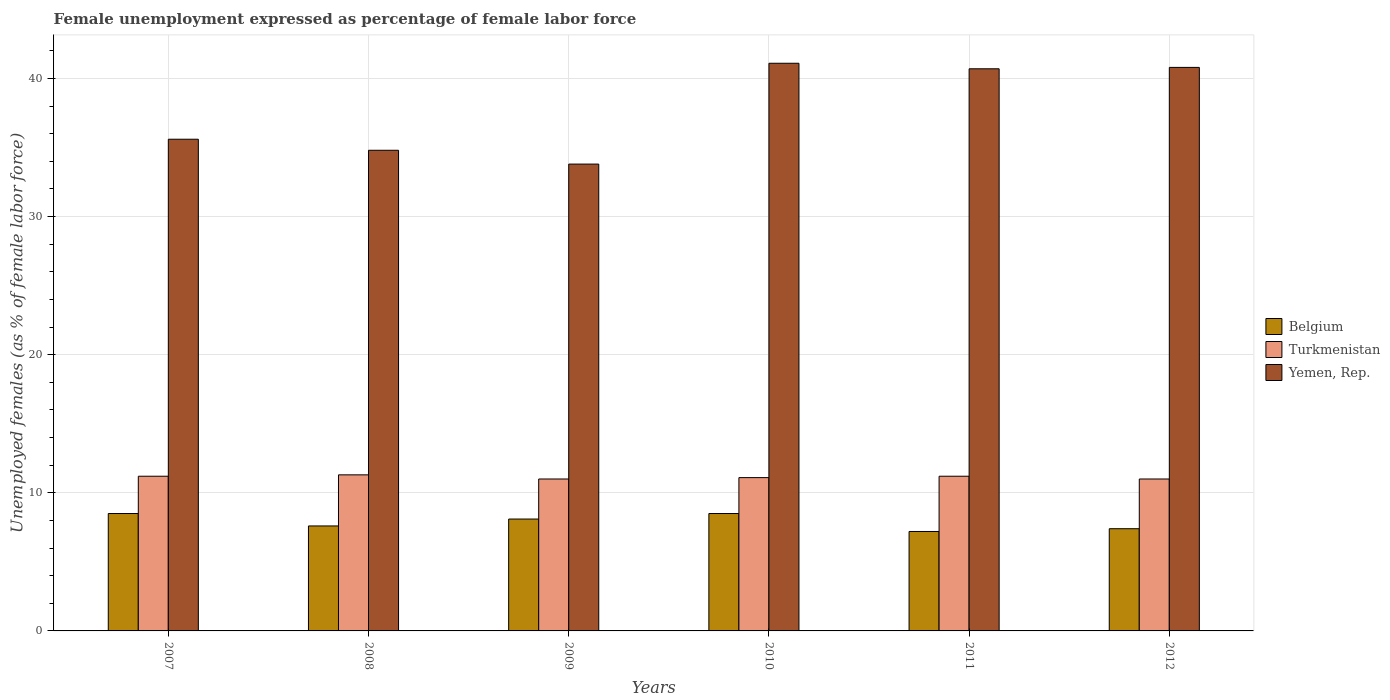How many different coloured bars are there?
Ensure brevity in your answer.  3. How many bars are there on the 4th tick from the left?
Ensure brevity in your answer.  3. What is the label of the 3rd group of bars from the left?
Offer a very short reply. 2009. In how many cases, is the number of bars for a given year not equal to the number of legend labels?
Keep it short and to the point. 0. What is the unemployment in females in in Belgium in 2007?
Provide a succinct answer. 8.5. Across all years, what is the maximum unemployment in females in in Belgium?
Provide a succinct answer. 8.5. In which year was the unemployment in females in in Turkmenistan minimum?
Keep it short and to the point. 2009. What is the total unemployment in females in in Turkmenistan in the graph?
Offer a terse response. 66.8. What is the difference between the unemployment in females in in Turkmenistan in 2009 and that in 2010?
Your answer should be very brief. -0.1. What is the difference between the unemployment in females in in Belgium in 2007 and the unemployment in females in in Yemen, Rep. in 2009?
Offer a terse response. -25.3. What is the average unemployment in females in in Belgium per year?
Ensure brevity in your answer.  7.88. In the year 2007, what is the difference between the unemployment in females in in Turkmenistan and unemployment in females in in Yemen, Rep.?
Your response must be concise. -24.4. What is the ratio of the unemployment in females in in Belgium in 2010 to that in 2012?
Provide a succinct answer. 1.15. Is the difference between the unemployment in females in in Turkmenistan in 2011 and 2012 greater than the difference between the unemployment in females in in Yemen, Rep. in 2011 and 2012?
Make the answer very short. Yes. What is the difference between the highest and the second highest unemployment in females in in Turkmenistan?
Your answer should be compact. 0.1. What is the difference between the highest and the lowest unemployment in females in in Turkmenistan?
Offer a very short reply. 0.3. What does the 3rd bar from the left in 2007 represents?
Make the answer very short. Yemen, Rep. What does the 1st bar from the right in 2010 represents?
Make the answer very short. Yemen, Rep. Is it the case that in every year, the sum of the unemployment in females in in Turkmenistan and unemployment in females in in Yemen, Rep. is greater than the unemployment in females in in Belgium?
Keep it short and to the point. Yes. What is the difference between two consecutive major ticks on the Y-axis?
Provide a succinct answer. 10. How many legend labels are there?
Offer a terse response. 3. What is the title of the graph?
Give a very brief answer. Female unemployment expressed as percentage of female labor force. What is the label or title of the Y-axis?
Provide a succinct answer. Unemployed females (as % of female labor force). What is the Unemployed females (as % of female labor force) of Turkmenistan in 2007?
Offer a very short reply. 11.2. What is the Unemployed females (as % of female labor force) of Yemen, Rep. in 2007?
Ensure brevity in your answer.  35.6. What is the Unemployed females (as % of female labor force) of Belgium in 2008?
Your answer should be very brief. 7.6. What is the Unemployed females (as % of female labor force) in Turkmenistan in 2008?
Provide a succinct answer. 11.3. What is the Unemployed females (as % of female labor force) in Yemen, Rep. in 2008?
Ensure brevity in your answer.  34.8. What is the Unemployed females (as % of female labor force) of Belgium in 2009?
Keep it short and to the point. 8.1. What is the Unemployed females (as % of female labor force) in Yemen, Rep. in 2009?
Your answer should be compact. 33.8. What is the Unemployed females (as % of female labor force) in Belgium in 2010?
Keep it short and to the point. 8.5. What is the Unemployed females (as % of female labor force) of Turkmenistan in 2010?
Provide a short and direct response. 11.1. What is the Unemployed females (as % of female labor force) in Yemen, Rep. in 2010?
Ensure brevity in your answer.  41.1. What is the Unemployed females (as % of female labor force) of Belgium in 2011?
Ensure brevity in your answer.  7.2. What is the Unemployed females (as % of female labor force) in Turkmenistan in 2011?
Give a very brief answer. 11.2. What is the Unemployed females (as % of female labor force) in Yemen, Rep. in 2011?
Give a very brief answer. 40.7. What is the Unemployed females (as % of female labor force) of Belgium in 2012?
Provide a succinct answer. 7.4. What is the Unemployed females (as % of female labor force) of Yemen, Rep. in 2012?
Your answer should be very brief. 40.8. Across all years, what is the maximum Unemployed females (as % of female labor force) of Belgium?
Keep it short and to the point. 8.5. Across all years, what is the maximum Unemployed females (as % of female labor force) of Turkmenistan?
Offer a terse response. 11.3. Across all years, what is the maximum Unemployed females (as % of female labor force) of Yemen, Rep.?
Make the answer very short. 41.1. Across all years, what is the minimum Unemployed females (as % of female labor force) in Belgium?
Your answer should be compact. 7.2. Across all years, what is the minimum Unemployed females (as % of female labor force) in Turkmenistan?
Provide a short and direct response. 11. Across all years, what is the minimum Unemployed females (as % of female labor force) of Yemen, Rep.?
Keep it short and to the point. 33.8. What is the total Unemployed females (as % of female labor force) in Belgium in the graph?
Give a very brief answer. 47.3. What is the total Unemployed females (as % of female labor force) of Turkmenistan in the graph?
Keep it short and to the point. 66.8. What is the total Unemployed females (as % of female labor force) of Yemen, Rep. in the graph?
Provide a succinct answer. 226.8. What is the difference between the Unemployed females (as % of female labor force) in Belgium in 2007 and that in 2008?
Provide a succinct answer. 0.9. What is the difference between the Unemployed females (as % of female labor force) of Yemen, Rep. in 2007 and that in 2008?
Offer a terse response. 0.8. What is the difference between the Unemployed females (as % of female labor force) in Belgium in 2007 and that in 2009?
Provide a succinct answer. 0.4. What is the difference between the Unemployed females (as % of female labor force) of Turkmenistan in 2007 and that in 2009?
Your answer should be compact. 0.2. What is the difference between the Unemployed females (as % of female labor force) of Belgium in 2007 and that in 2012?
Make the answer very short. 1.1. What is the difference between the Unemployed females (as % of female labor force) of Yemen, Rep. in 2007 and that in 2012?
Provide a succinct answer. -5.2. What is the difference between the Unemployed females (as % of female labor force) in Belgium in 2008 and that in 2009?
Your response must be concise. -0.5. What is the difference between the Unemployed females (as % of female labor force) of Turkmenistan in 2008 and that in 2010?
Give a very brief answer. 0.2. What is the difference between the Unemployed females (as % of female labor force) in Yemen, Rep. in 2008 and that in 2010?
Your answer should be compact. -6.3. What is the difference between the Unemployed females (as % of female labor force) of Yemen, Rep. in 2008 and that in 2011?
Make the answer very short. -5.9. What is the difference between the Unemployed females (as % of female labor force) in Yemen, Rep. in 2008 and that in 2012?
Provide a succinct answer. -6. What is the difference between the Unemployed females (as % of female labor force) in Belgium in 2009 and that in 2011?
Ensure brevity in your answer.  0.9. What is the difference between the Unemployed females (as % of female labor force) of Yemen, Rep. in 2009 and that in 2011?
Give a very brief answer. -6.9. What is the difference between the Unemployed females (as % of female labor force) in Yemen, Rep. in 2009 and that in 2012?
Provide a short and direct response. -7. What is the difference between the Unemployed females (as % of female labor force) of Belgium in 2010 and that in 2011?
Provide a succinct answer. 1.3. What is the difference between the Unemployed females (as % of female labor force) of Turkmenistan in 2010 and that in 2011?
Ensure brevity in your answer.  -0.1. What is the difference between the Unemployed females (as % of female labor force) in Yemen, Rep. in 2010 and that in 2011?
Your answer should be very brief. 0.4. What is the difference between the Unemployed females (as % of female labor force) of Turkmenistan in 2010 and that in 2012?
Provide a short and direct response. 0.1. What is the difference between the Unemployed females (as % of female labor force) in Belgium in 2011 and that in 2012?
Keep it short and to the point. -0.2. What is the difference between the Unemployed females (as % of female labor force) in Turkmenistan in 2011 and that in 2012?
Offer a very short reply. 0.2. What is the difference between the Unemployed females (as % of female labor force) of Belgium in 2007 and the Unemployed females (as % of female labor force) of Turkmenistan in 2008?
Make the answer very short. -2.8. What is the difference between the Unemployed females (as % of female labor force) in Belgium in 2007 and the Unemployed females (as % of female labor force) in Yemen, Rep. in 2008?
Your response must be concise. -26.3. What is the difference between the Unemployed females (as % of female labor force) in Turkmenistan in 2007 and the Unemployed females (as % of female labor force) in Yemen, Rep. in 2008?
Give a very brief answer. -23.6. What is the difference between the Unemployed females (as % of female labor force) of Belgium in 2007 and the Unemployed females (as % of female labor force) of Yemen, Rep. in 2009?
Provide a succinct answer. -25.3. What is the difference between the Unemployed females (as % of female labor force) of Turkmenistan in 2007 and the Unemployed females (as % of female labor force) of Yemen, Rep. in 2009?
Ensure brevity in your answer.  -22.6. What is the difference between the Unemployed females (as % of female labor force) of Belgium in 2007 and the Unemployed females (as % of female labor force) of Yemen, Rep. in 2010?
Offer a terse response. -32.6. What is the difference between the Unemployed females (as % of female labor force) in Turkmenistan in 2007 and the Unemployed females (as % of female labor force) in Yemen, Rep. in 2010?
Ensure brevity in your answer.  -29.9. What is the difference between the Unemployed females (as % of female labor force) in Belgium in 2007 and the Unemployed females (as % of female labor force) in Turkmenistan in 2011?
Ensure brevity in your answer.  -2.7. What is the difference between the Unemployed females (as % of female labor force) in Belgium in 2007 and the Unemployed females (as % of female labor force) in Yemen, Rep. in 2011?
Your answer should be very brief. -32.2. What is the difference between the Unemployed females (as % of female labor force) in Turkmenistan in 2007 and the Unemployed females (as % of female labor force) in Yemen, Rep. in 2011?
Provide a succinct answer. -29.5. What is the difference between the Unemployed females (as % of female labor force) in Belgium in 2007 and the Unemployed females (as % of female labor force) in Yemen, Rep. in 2012?
Keep it short and to the point. -32.3. What is the difference between the Unemployed females (as % of female labor force) in Turkmenistan in 2007 and the Unemployed females (as % of female labor force) in Yemen, Rep. in 2012?
Provide a succinct answer. -29.6. What is the difference between the Unemployed females (as % of female labor force) in Belgium in 2008 and the Unemployed females (as % of female labor force) in Yemen, Rep. in 2009?
Ensure brevity in your answer.  -26.2. What is the difference between the Unemployed females (as % of female labor force) of Turkmenistan in 2008 and the Unemployed females (as % of female labor force) of Yemen, Rep. in 2009?
Keep it short and to the point. -22.5. What is the difference between the Unemployed females (as % of female labor force) of Belgium in 2008 and the Unemployed females (as % of female labor force) of Turkmenistan in 2010?
Your answer should be compact. -3.5. What is the difference between the Unemployed females (as % of female labor force) in Belgium in 2008 and the Unemployed females (as % of female labor force) in Yemen, Rep. in 2010?
Make the answer very short. -33.5. What is the difference between the Unemployed females (as % of female labor force) in Turkmenistan in 2008 and the Unemployed females (as % of female labor force) in Yemen, Rep. in 2010?
Give a very brief answer. -29.8. What is the difference between the Unemployed females (as % of female labor force) of Belgium in 2008 and the Unemployed females (as % of female labor force) of Turkmenistan in 2011?
Provide a succinct answer. -3.6. What is the difference between the Unemployed females (as % of female labor force) in Belgium in 2008 and the Unemployed females (as % of female labor force) in Yemen, Rep. in 2011?
Your response must be concise. -33.1. What is the difference between the Unemployed females (as % of female labor force) of Turkmenistan in 2008 and the Unemployed females (as % of female labor force) of Yemen, Rep. in 2011?
Your response must be concise. -29.4. What is the difference between the Unemployed females (as % of female labor force) of Belgium in 2008 and the Unemployed females (as % of female labor force) of Turkmenistan in 2012?
Keep it short and to the point. -3.4. What is the difference between the Unemployed females (as % of female labor force) of Belgium in 2008 and the Unemployed females (as % of female labor force) of Yemen, Rep. in 2012?
Offer a very short reply. -33.2. What is the difference between the Unemployed females (as % of female labor force) in Turkmenistan in 2008 and the Unemployed females (as % of female labor force) in Yemen, Rep. in 2012?
Your answer should be compact. -29.5. What is the difference between the Unemployed females (as % of female labor force) in Belgium in 2009 and the Unemployed females (as % of female labor force) in Yemen, Rep. in 2010?
Ensure brevity in your answer.  -33. What is the difference between the Unemployed females (as % of female labor force) in Turkmenistan in 2009 and the Unemployed females (as % of female labor force) in Yemen, Rep. in 2010?
Your answer should be very brief. -30.1. What is the difference between the Unemployed females (as % of female labor force) of Belgium in 2009 and the Unemployed females (as % of female labor force) of Yemen, Rep. in 2011?
Offer a terse response. -32.6. What is the difference between the Unemployed females (as % of female labor force) in Turkmenistan in 2009 and the Unemployed females (as % of female labor force) in Yemen, Rep. in 2011?
Offer a very short reply. -29.7. What is the difference between the Unemployed females (as % of female labor force) in Belgium in 2009 and the Unemployed females (as % of female labor force) in Turkmenistan in 2012?
Ensure brevity in your answer.  -2.9. What is the difference between the Unemployed females (as % of female labor force) of Belgium in 2009 and the Unemployed females (as % of female labor force) of Yemen, Rep. in 2012?
Give a very brief answer. -32.7. What is the difference between the Unemployed females (as % of female labor force) in Turkmenistan in 2009 and the Unemployed females (as % of female labor force) in Yemen, Rep. in 2012?
Offer a terse response. -29.8. What is the difference between the Unemployed females (as % of female labor force) of Belgium in 2010 and the Unemployed females (as % of female labor force) of Turkmenistan in 2011?
Offer a terse response. -2.7. What is the difference between the Unemployed females (as % of female labor force) of Belgium in 2010 and the Unemployed females (as % of female labor force) of Yemen, Rep. in 2011?
Provide a succinct answer. -32.2. What is the difference between the Unemployed females (as % of female labor force) of Turkmenistan in 2010 and the Unemployed females (as % of female labor force) of Yemen, Rep. in 2011?
Offer a very short reply. -29.6. What is the difference between the Unemployed females (as % of female labor force) in Belgium in 2010 and the Unemployed females (as % of female labor force) in Turkmenistan in 2012?
Your answer should be very brief. -2.5. What is the difference between the Unemployed females (as % of female labor force) in Belgium in 2010 and the Unemployed females (as % of female labor force) in Yemen, Rep. in 2012?
Ensure brevity in your answer.  -32.3. What is the difference between the Unemployed females (as % of female labor force) in Turkmenistan in 2010 and the Unemployed females (as % of female labor force) in Yemen, Rep. in 2012?
Your answer should be very brief. -29.7. What is the difference between the Unemployed females (as % of female labor force) of Belgium in 2011 and the Unemployed females (as % of female labor force) of Turkmenistan in 2012?
Provide a short and direct response. -3.8. What is the difference between the Unemployed females (as % of female labor force) in Belgium in 2011 and the Unemployed females (as % of female labor force) in Yemen, Rep. in 2012?
Provide a short and direct response. -33.6. What is the difference between the Unemployed females (as % of female labor force) of Turkmenistan in 2011 and the Unemployed females (as % of female labor force) of Yemen, Rep. in 2012?
Give a very brief answer. -29.6. What is the average Unemployed females (as % of female labor force) of Belgium per year?
Your response must be concise. 7.88. What is the average Unemployed females (as % of female labor force) in Turkmenistan per year?
Your answer should be very brief. 11.13. What is the average Unemployed females (as % of female labor force) in Yemen, Rep. per year?
Give a very brief answer. 37.8. In the year 2007, what is the difference between the Unemployed females (as % of female labor force) in Belgium and Unemployed females (as % of female labor force) in Yemen, Rep.?
Your answer should be compact. -27.1. In the year 2007, what is the difference between the Unemployed females (as % of female labor force) of Turkmenistan and Unemployed females (as % of female labor force) of Yemen, Rep.?
Your answer should be compact. -24.4. In the year 2008, what is the difference between the Unemployed females (as % of female labor force) in Belgium and Unemployed females (as % of female labor force) in Yemen, Rep.?
Offer a terse response. -27.2. In the year 2008, what is the difference between the Unemployed females (as % of female labor force) in Turkmenistan and Unemployed females (as % of female labor force) in Yemen, Rep.?
Provide a short and direct response. -23.5. In the year 2009, what is the difference between the Unemployed females (as % of female labor force) in Belgium and Unemployed females (as % of female labor force) in Turkmenistan?
Give a very brief answer. -2.9. In the year 2009, what is the difference between the Unemployed females (as % of female labor force) of Belgium and Unemployed females (as % of female labor force) of Yemen, Rep.?
Ensure brevity in your answer.  -25.7. In the year 2009, what is the difference between the Unemployed females (as % of female labor force) in Turkmenistan and Unemployed females (as % of female labor force) in Yemen, Rep.?
Your response must be concise. -22.8. In the year 2010, what is the difference between the Unemployed females (as % of female labor force) of Belgium and Unemployed females (as % of female labor force) of Yemen, Rep.?
Your answer should be compact. -32.6. In the year 2010, what is the difference between the Unemployed females (as % of female labor force) in Turkmenistan and Unemployed females (as % of female labor force) in Yemen, Rep.?
Offer a terse response. -30. In the year 2011, what is the difference between the Unemployed females (as % of female labor force) of Belgium and Unemployed females (as % of female labor force) of Yemen, Rep.?
Offer a terse response. -33.5. In the year 2011, what is the difference between the Unemployed females (as % of female labor force) of Turkmenistan and Unemployed females (as % of female labor force) of Yemen, Rep.?
Offer a very short reply. -29.5. In the year 2012, what is the difference between the Unemployed females (as % of female labor force) in Belgium and Unemployed females (as % of female labor force) in Turkmenistan?
Make the answer very short. -3.6. In the year 2012, what is the difference between the Unemployed females (as % of female labor force) of Belgium and Unemployed females (as % of female labor force) of Yemen, Rep.?
Your answer should be very brief. -33.4. In the year 2012, what is the difference between the Unemployed females (as % of female labor force) in Turkmenistan and Unemployed females (as % of female labor force) in Yemen, Rep.?
Offer a terse response. -29.8. What is the ratio of the Unemployed females (as % of female labor force) of Belgium in 2007 to that in 2008?
Offer a terse response. 1.12. What is the ratio of the Unemployed females (as % of female labor force) of Turkmenistan in 2007 to that in 2008?
Ensure brevity in your answer.  0.99. What is the ratio of the Unemployed females (as % of female labor force) of Belgium in 2007 to that in 2009?
Your response must be concise. 1.05. What is the ratio of the Unemployed females (as % of female labor force) of Turkmenistan in 2007 to that in 2009?
Provide a succinct answer. 1.02. What is the ratio of the Unemployed females (as % of female labor force) in Yemen, Rep. in 2007 to that in 2009?
Offer a terse response. 1.05. What is the ratio of the Unemployed females (as % of female labor force) in Yemen, Rep. in 2007 to that in 2010?
Your answer should be very brief. 0.87. What is the ratio of the Unemployed females (as % of female labor force) in Belgium in 2007 to that in 2011?
Your answer should be compact. 1.18. What is the ratio of the Unemployed females (as % of female labor force) in Yemen, Rep. in 2007 to that in 2011?
Provide a short and direct response. 0.87. What is the ratio of the Unemployed females (as % of female labor force) of Belgium in 2007 to that in 2012?
Ensure brevity in your answer.  1.15. What is the ratio of the Unemployed females (as % of female labor force) in Turkmenistan in 2007 to that in 2012?
Provide a short and direct response. 1.02. What is the ratio of the Unemployed females (as % of female labor force) of Yemen, Rep. in 2007 to that in 2012?
Offer a very short reply. 0.87. What is the ratio of the Unemployed females (as % of female labor force) of Belgium in 2008 to that in 2009?
Your answer should be very brief. 0.94. What is the ratio of the Unemployed females (as % of female labor force) of Turkmenistan in 2008 to that in 2009?
Provide a short and direct response. 1.03. What is the ratio of the Unemployed females (as % of female labor force) in Yemen, Rep. in 2008 to that in 2009?
Offer a very short reply. 1.03. What is the ratio of the Unemployed females (as % of female labor force) in Belgium in 2008 to that in 2010?
Make the answer very short. 0.89. What is the ratio of the Unemployed females (as % of female labor force) of Turkmenistan in 2008 to that in 2010?
Keep it short and to the point. 1.02. What is the ratio of the Unemployed females (as % of female labor force) of Yemen, Rep. in 2008 to that in 2010?
Ensure brevity in your answer.  0.85. What is the ratio of the Unemployed females (as % of female labor force) of Belgium in 2008 to that in 2011?
Your response must be concise. 1.06. What is the ratio of the Unemployed females (as % of female labor force) of Turkmenistan in 2008 to that in 2011?
Provide a short and direct response. 1.01. What is the ratio of the Unemployed females (as % of female labor force) in Yemen, Rep. in 2008 to that in 2011?
Offer a terse response. 0.85. What is the ratio of the Unemployed females (as % of female labor force) of Belgium in 2008 to that in 2012?
Provide a succinct answer. 1.03. What is the ratio of the Unemployed females (as % of female labor force) in Turkmenistan in 2008 to that in 2012?
Provide a succinct answer. 1.03. What is the ratio of the Unemployed females (as % of female labor force) in Yemen, Rep. in 2008 to that in 2012?
Keep it short and to the point. 0.85. What is the ratio of the Unemployed females (as % of female labor force) in Belgium in 2009 to that in 2010?
Make the answer very short. 0.95. What is the ratio of the Unemployed females (as % of female labor force) in Turkmenistan in 2009 to that in 2010?
Offer a terse response. 0.99. What is the ratio of the Unemployed females (as % of female labor force) in Yemen, Rep. in 2009 to that in 2010?
Keep it short and to the point. 0.82. What is the ratio of the Unemployed females (as % of female labor force) of Belgium in 2009 to that in 2011?
Provide a short and direct response. 1.12. What is the ratio of the Unemployed females (as % of female labor force) in Turkmenistan in 2009 to that in 2011?
Make the answer very short. 0.98. What is the ratio of the Unemployed females (as % of female labor force) in Yemen, Rep. in 2009 to that in 2011?
Your answer should be compact. 0.83. What is the ratio of the Unemployed females (as % of female labor force) in Belgium in 2009 to that in 2012?
Provide a short and direct response. 1.09. What is the ratio of the Unemployed females (as % of female labor force) of Yemen, Rep. in 2009 to that in 2012?
Provide a succinct answer. 0.83. What is the ratio of the Unemployed females (as % of female labor force) of Belgium in 2010 to that in 2011?
Offer a very short reply. 1.18. What is the ratio of the Unemployed females (as % of female labor force) in Yemen, Rep. in 2010 to that in 2011?
Provide a short and direct response. 1.01. What is the ratio of the Unemployed females (as % of female labor force) in Belgium in 2010 to that in 2012?
Make the answer very short. 1.15. What is the ratio of the Unemployed females (as % of female labor force) in Turkmenistan in 2010 to that in 2012?
Keep it short and to the point. 1.01. What is the ratio of the Unemployed females (as % of female labor force) in Yemen, Rep. in 2010 to that in 2012?
Make the answer very short. 1.01. What is the ratio of the Unemployed females (as % of female labor force) of Turkmenistan in 2011 to that in 2012?
Offer a very short reply. 1.02. What is the ratio of the Unemployed females (as % of female labor force) in Yemen, Rep. in 2011 to that in 2012?
Provide a short and direct response. 1. What is the difference between the highest and the second highest Unemployed females (as % of female labor force) of Yemen, Rep.?
Your response must be concise. 0.3. What is the difference between the highest and the lowest Unemployed females (as % of female labor force) of Belgium?
Give a very brief answer. 1.3. What is the difference between the highest and the lowest Unemployed females (as % of female labor force) in Turkmenistan?
Provide a short and direct response. 0.3. What is the difference between the highest and the lowest Unemployed females (as % of female labor force) of Yemen, Rep.?
Your answer should be compact. 7.3. 